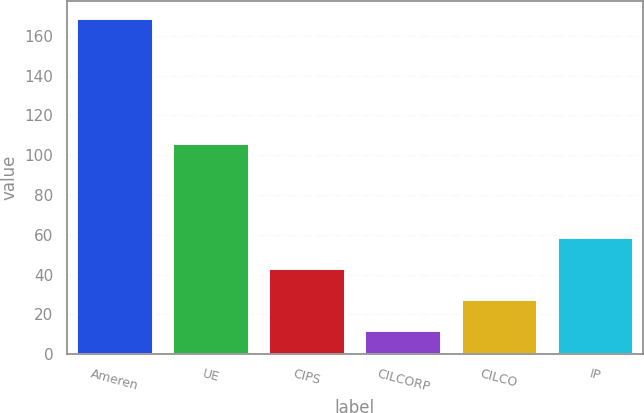Convert chart to OTSL. <chart><loc_0><loc_0><loc_500><loc_500><bar_chart><fcel>Ameren<fcel>UE<fcel>CIPS<fcel>CILCORP<fcel>CILCO<fcel>IP<nl><fcel>169<fcel>106<fcel>43.4<fcel>12<fcel>27.7<fcel>59.1<nl></chart> 